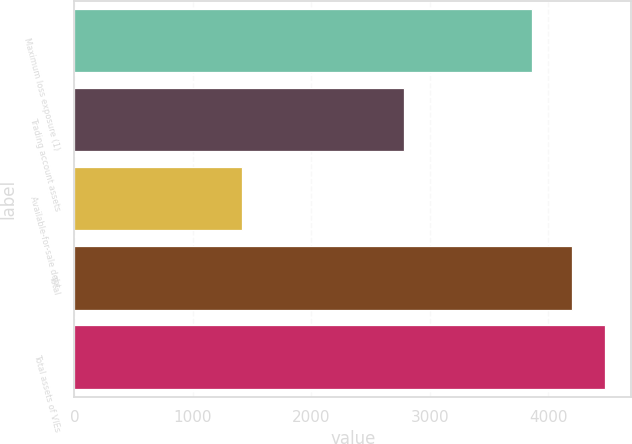Convert chart to OTSL. <chart><loc_0><loc_0><loc_500><loc_500><bar_chart><fcel>Maximum loss exposure (1)<fcel>Trading account assets<fcel>Available-for-sale debt<fcel>Total<fcel>Total assets of VIEs<nl><fcel>3863<fcel>2785<fcel>1414<fcel>4199<fcel>4477.5<nl></chart> 